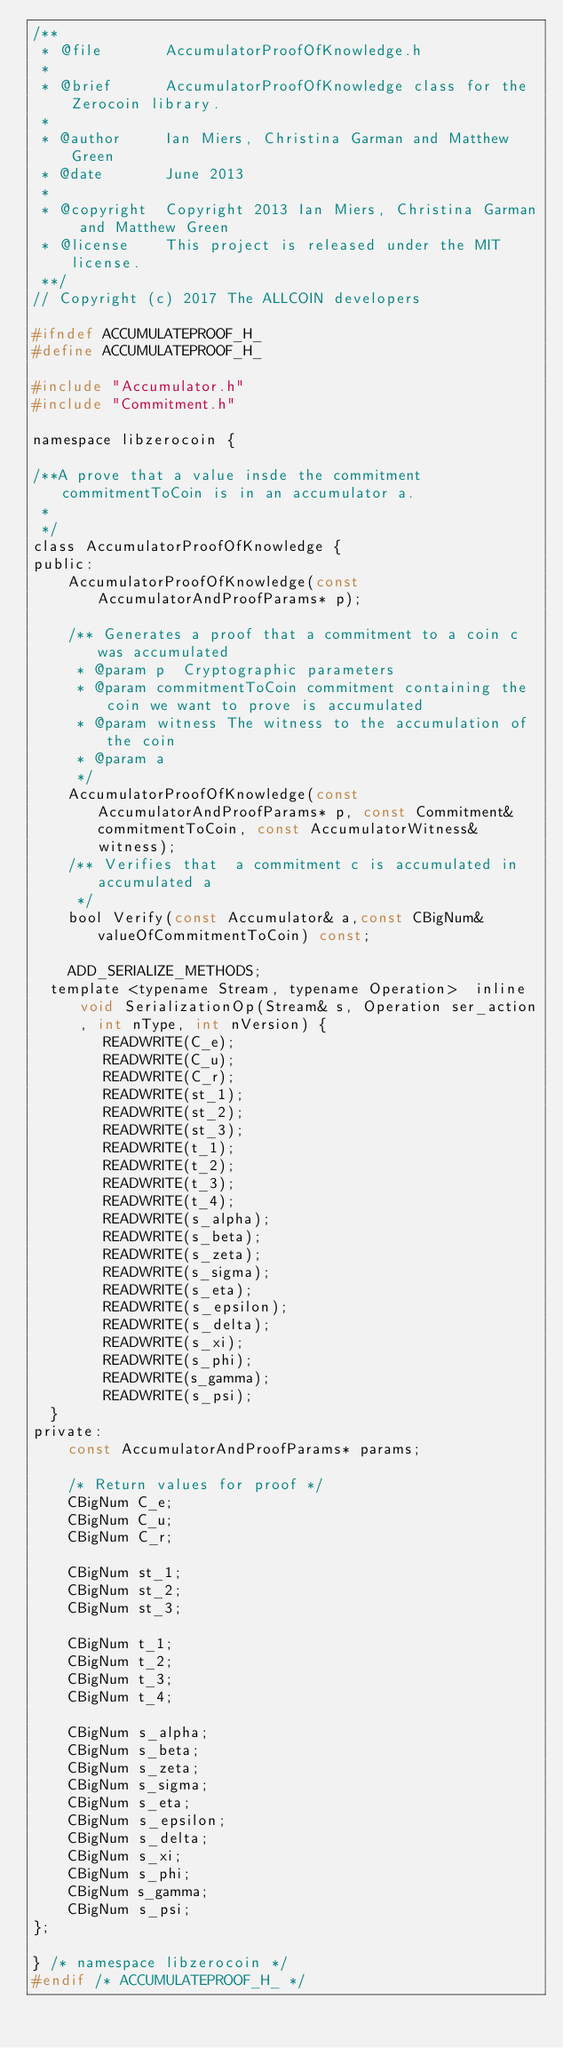Convert code to text. <code><loc_0><loc_0><loc_500><loc_500><_C_>/**
 * @file       AccumulatorProofOfKnowledge.h
 *
 * @brief      AccumulatorProofOfKnowledge class for the Zerocoin library.
 *
 * @author     Ian Miers, Christina Garman and Matthew Green
 * @date       June 2013
 *
 * @copyright  Copyright 2013 Ian Miers, Christina Garman and Matthew Green
 * @license    This project is released under the MIT license.
 **/
// Copyright (c) 2017 The ALLCOIN developers

#ifndef ACCUMULATEPROOF_H_
#define ACCUMULATEPROOF_H_

#include "Accumulator.h"
#include "Commitment.h"

namespace libzerocoin {

/**A prove that a value insde the commitment commitmentToCoin is in an accumulator a.
 *
 */
class AccumulatorProofOfKnowledge {
public:
	AccumulatorProofOfKnowledge(const AccumulatorAndProofParams* p);

	/** Generates a proof that a commitment to a coin c was accumulated
	 * @param p  Cryptographic parameters
	 * @param commitmentToCoin commitment containing the coin we want to prove is accumulated
	 * @param witness The witness to the accumulation of the coin
	 * @param a
	 */
    AccumulatorProofOfKnowledge(const AccumulatorAndProofParams* p, const Commitment& commitmentToCoin, const AccumulatorWitness& witness);
	/** Verifies that  a commitment c is accumulated in accumulated a
	 */
	bool Verify(const Accumulator& a,const CBigNum& valueOfCommitmentToCoin) const;
	
	ADD_SERIALIZE_METHODS;
  template <typename Stream, typename Operation>  inline void SerializationOp(Stream& s, Operation ser_action, int nType, int nVersion) {
	    READWRITE(C_e);
	    READWRITE(C_u);
	    READWRITE(C_r);
	    READWRITE(st_1);
	    READWRITE(st_2);
	    READWRITE(st_3);
	    READWRITE(t_1);
	    READWRITE(t_2);
	    READWRITE(t_3);
	    READWRITE(t_4);
	    READWRITE(s_alpha);
	    READWRITE(s_beta);
	    READWRITE(s_zeta);
	    READWRITE(s_sigma);
	    READWRITE(s_eta);
	    READWRITE(s_epsilon);
	    READWRITE(s_delta);
	    READWRITE(s_xi);
	    READWRITE(s_phi);
	    READWRITE(s_gamma);
	    READWRITE(s_psi);
  }	
private:
	const AccumulatorAndProofParams* params;

	/* Return values for proof */
	CBigNum C_e;
	CBigNum C_u;
	CBigNum C_r;

	CBigNum st_1;
	CBigNum st_2;
	CBigNum st_3;

	CBigNum t_1;
	CBigNum t_2;
	CBigNum t_3;
	CBigNum t_4;

	CBigNum s_alpha;
	CBigNum s_beta;
	CBigNum s_zeta;
	CBigNum s_sigma;
	CBigNum s_eta;
	CBigNum s_epsilon;
	CBigNum s_delta;
	CBigNum s_xi;
	CBigNum s_phi;
	CBigNum s_gamma;
	CBigNum s_psi;
};

} /* namespace libzerocoin */
#endif /* ACCUMULATEPROOF_H_ */
</code> 